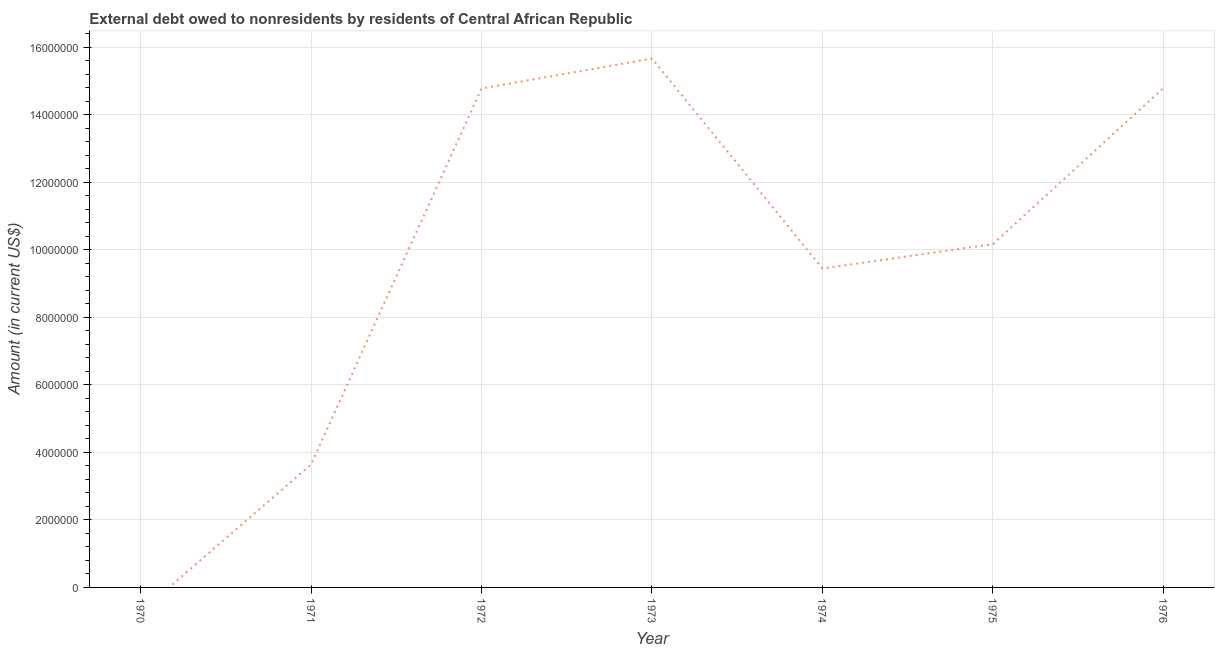What is the debt in 1976?
Provide a short and direct response. 1.48e+07. Across all years, what is the maximum debt?
Your response must be concise. 1.57e+07. Across all years, what is the minimum debt?
Provide a succinct answer. 0. What is the sum of the debt?
Offer a very short reply. 6.85e+07. What is the difference between the debt in 1972 and 1976?
Keep it short and to the point. -1.30e+04. What is the average debt per year?
Your answer should be compact. 9.79e+06. What is the median debt?
Offer a terse response. 1.02e+07. What is the ratio of the debt in 1972 to that in 1974?
Make the answer very short. 1.56. Is the difference between the debt in 1972 and 1976 greater than the difference between any two years?
Your answer should be very brief. No. What is the difference between the highest and the second highest debt?
Provide a short and direct response. 8.76e+05. Is the sum of the debt in 1971 and 1976 greater than the maximum debt across all years?
Provide a short and direct response. Yes. What is the difference between the highest and the lowest debt?
Provide a succinct answer. 1.57e+07. How many lines are there?
Offer a very short reply. 1. How many years are there in the graph?
Offer a terse response. 7. What is the difference between two consecutive major ticks on the Y-axis?
Ensure brevity in your answer.  2.00e+06. Does the graph contain grids?
Ensure brevity in your answer.  Yes. What is the title of the graph?
Ensure brevity in your answer.  External debt owed to nonresidents by residents of Central African Republic. What is the label or title of the Y-axis?
Your answer should be compact. Amount (in current US$). What is the Amount (in current US$) of 1971?
Your response must be concise. 3.64e+06. What is the Amount (in current US$) in 1972?
Offer a terse response. 1.48e+07. What is the Amount (in current US$) in 1973?
Provide a succinct answer. 1.57e+07. What is the Amount (in current US$) in 1974?
Give a very brief answer. 9.45e+06. What is the Amount (in current US$) of 1975?
Your answer should be very brief. 1.02e+07. What is the Amount (in current US$) of 1976?
Your answer should be very brief. 1.48e+07. What is the difference between the Amount (in current US$) in 1971 and 1972?
Your answer should be compact. -1.11e+07. What is the difference between the Amount (in current US$) in 1971 and 1973?
Ensure brevity in your answer.  -1.20e+07. What is the difference between the Amount (in current US$) in 1971 and 1974?
Offer a terse response. -5.80e+06. What is the difference between the Amount (in current US$) in 1971 and 1975?
Your answer should be compact. -6.53e+06. What is the difference between the Amount (in current US$) in 1971 and 1976?
Give a very brief answer. -1.12e+07. What is the difference between the Amount (in current US$) in 1972 and 1973?
Offer a very short reply. -8.89e+05. What is the difference between the Amount (in current US$) in 1972 and 1974?
Provide a short and direct response. 5.33e+06. What is the difference between the Amount (in current US$) in 1972 and 1975?
Keep it short and to the point. 4.61e+06. What is the difference between the Amount (in current US$) in 1972 and 1976?
Provide a succinct answer. -1.30e+04. What is the difference between the Amount (in current US$) in 1973 and 1974?
Give a very brief answer. 6.22e+06. What is the difference between the Amount (in current US$) in 1973 and 1975?
Your answer should be very brief. 5.50e+06. What is the difference between the Amount (in current US$) in 1973 and 1976?
Your answer should be compact. 8.76e+05. What is the difference between the Amount (in current US$) in 1974 and 1975?
Provide a short and direct response. -7.23e+05. What is the difference between the Amount (in current US$) in 1974 and 1976?
Your response must be concise. -5.34e+06. What is the difference between the Amount (in current US$) in 1975 and 1976?
Your response must be concise. -4.62e+06. What is the ratio of the Amount (in current US$) in 1971 to that in 1972?
Ensure brevity in your answer.  0.25. What is the ratio of the Amount (in current US$) in 1971 to that in 1973?
Make the answer very short. 0.23. What is the ratio of the Amount (in current US$) in 1971 to that in 1974?
Offer a very short reply. 0.39. What is the ratio of the Amount (in current US$) in 1971 to that in 1975?
Your response must be concise. 0.36. What is the ratio of the Amount (in current US$) in 1971 to that in 1976?
Your answer should be very brief. 0.25. What is the ratio of the Amount (in current US$) in 1972 to that in 1973?
Offer a very short reply. 0.94. What is the ratio of the Amount (in current US$) in 1972 to that in 1974?
Give a very brief answer. 1.56. What is the ratio of the Amount (in current US$) in 1972 to that in 1975?
Your response must be concise. 1.45. What is the ratio of the Amount (in current US$) in 1973 to that in 1974?
Your response must be concise. 1.66. What is the ratio of the Amount (in current US$) in 1973 to that in 1975?
Provide a succinct answer. 1.54. What is the ratio of the Amount (in current US$) in 1973 to that in 1976?
Provide a short and direct response. 1.06. What is the ratio of the Amount (in current US$) in 1974 to that in 1975?
Offer a very short reply. 0.93. What is the ratio of the Amount (in current US$) in 1974 to that in 1976?
Offer a terse response. 0.64. What is the ratio of the Amount (in current US$) in 1975 to that in 1976?
Ensure brevity in your answer.  0.69. 